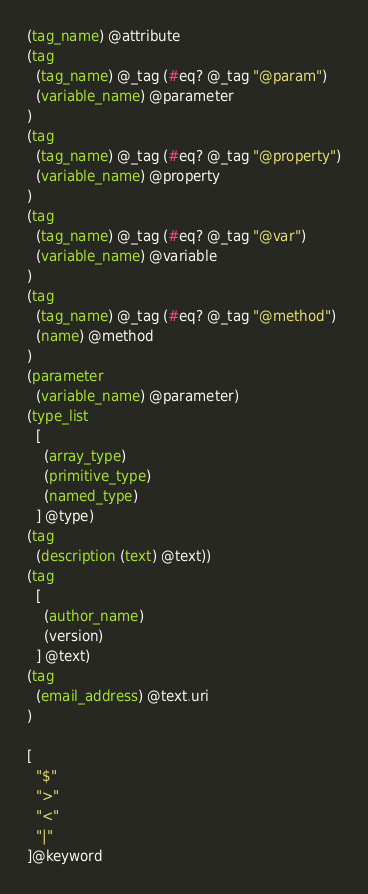<code> <loc_0><loc_0><loc_500><loc_500><_Scheme_>(tag_name) @attribute
(tag
  (tag_name) @_tag (#eq? @_tag "@param")
  (variable_name) @parameter
)
(tag
  (tag_name) @_tag (#eq? @_tag "@property")
  (variable_name) @property
)
(tag
  (tag_name) @_tag (#eq? @_tag "@var")
  (variable_name) @variable
)
(tag
  (tag_name) @_tag (#eq? @_tag "@method")
  (name) @method
)
(parameter
  (variable_name) @parameter)
(type_list
  [
    (array_type)
    (primitive_type)
    (named_type)
  ] @type)
(tag
  (description (text) @text))
(tag
  [
    (author_name)
    (version)
  ] @text)
(tag
  (email_address) @text.uri
)

[
  "$"
  ">"
  "<"
  "|"
]@keyword
</code> 